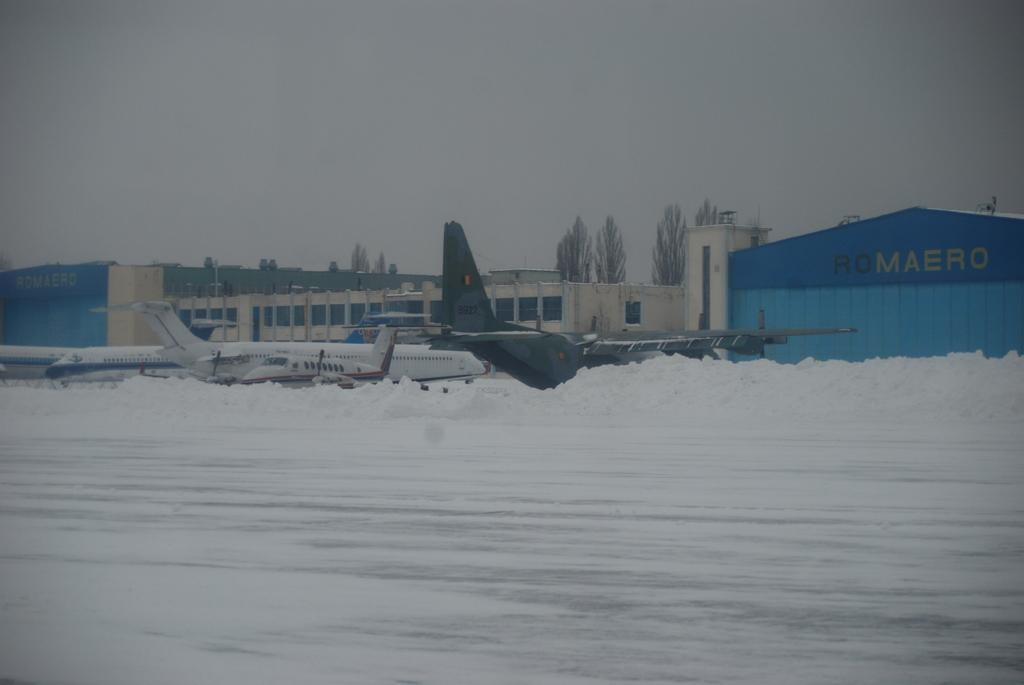What can be seen on the ground in the image? There are planes parked on the ground in the image. What type of structure is visible in the background? There is a white color building in the background. What is the color of the tent in the background? The tent in the background has a blue color shade. What type of natural elements can be seen in the background? There are trees visible in the background. What type of art is being displayed on the planes in the image? There is no art displayed on the planes in the image; they are parked without any decoration. 